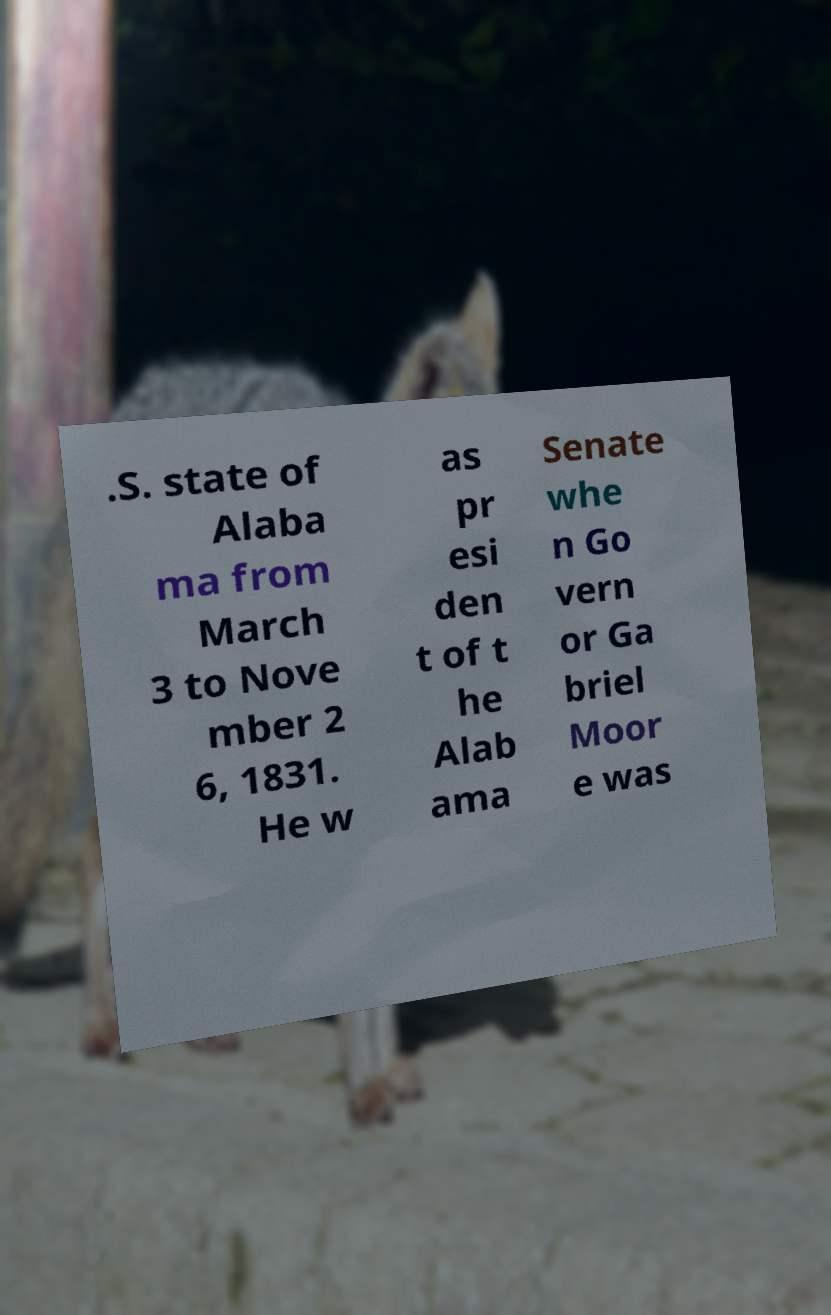What messages or text are displayed in this image? I need them in a readable, typed format. .S. state of Alaba ma from March 3 to Nove mber 2 6, 1831. He w as pr esi den t of t he Alab ama Senate whe n Go vern or Ga briel Moor e was 